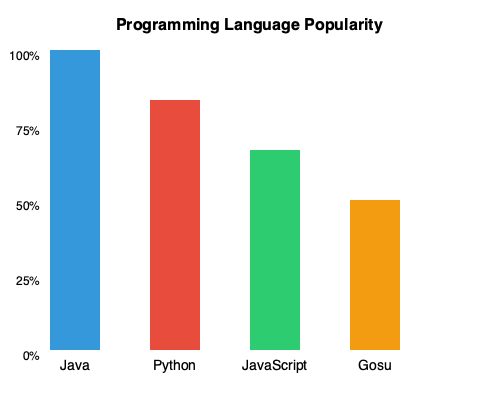Based on the bar chart comparing popular programming languages, what is the difference in popularity percentage between Python and Gosu? To find the difference in popularity percentage between Python and Gosu, we need to follow these steps:

1. Identify the bars representing Python and Gosu:
   - Python is the second bar from the left (red)
   - Gosu is the rightmost bar (orange)

2. Determine the popularity percentages:
   - Python's bar reaches the 75% mark
   - Gosu's bar reaches the 50% mark

3. Calculate the difference:
   $75\% - 50\% = 25\%$

Therefore, the difference in popularity percentage between Python and Gosu is 25%.
Answer: 25% 